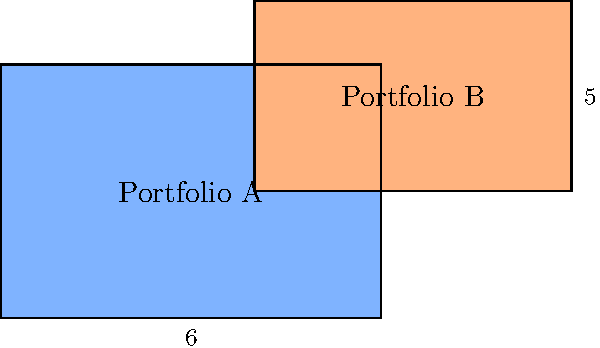Two investment portfolios are represented by overlapping rectangles in the diagram above. Portfolio A is represented by a 6 x 4 rectangle, while Portfolio B is represented by a 5 x 3 rectangle. The overlapping area represents shared investments. What is the total area covered by both portfolios combined? To calculate the total area covered by both portfolios, we need to:

1. Calculate the area of Portfolio A:
   $A_A = 6 \times 4 = 24$ square units

2. Calculate the area of Portfolio B:
   $A_B = 5 \times 3 = 15$ square units

3. Calculate the overlapping area:
   Width of overlap = $6 - 4 = 2$ units
   Height of overlap = $3$ units
   $A_{overlap} = 2 \times 3 = 6$ square units

4. Calculate the total area by adding the areas of both portfolios and subtracting the overlapping area to avoid double-counting:
   $A_{total} = A_A + A_B - A_{overlap}$
   $A_{total} = 24 + 15 - 6 = 33$ square units

Therefore, the total area covered by both portfolios combined is 33 square units.
Answer: 33 square units 